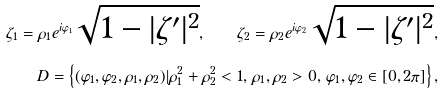<formula> <loc_0><loc_0><loc_500><loc_500>\zeta _ { 1 } = \rho _ { 1 } e ^ { i \varphi _ { 1 } } \sqrt { 1 - | \zeta ^ { \prime } | ^ { 2 } } , \quad \zeta _ { 2 } = \rho _ { 2 } e ^ { i \varphi _ { 2 } } \sqrt { 1 - | \zeta ^ { \prime } | ^ { 2 } } , \\ D = \left \{ ( \varphi _ { 1 } , \varphi _ { 2 } , \rho _ { 1 } , \rho _ { 2 } ) | \rho _ { 1 } ^ { 2 } + \rho _ { 2 } ^ { 2 } < 1 , \, \rho _ { 1 } , \rho _ { 2 } > 0 , \, \varphi _ { 1 } , \varphi _ { 2 } \in [ 0 , 2 \pi ] \right \} ,</formula> 